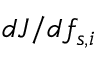Convert formula to latex. <formula><loc_0><loc_0><loc_500><loc_500>{ d J } / { d f _ { s , i } }</formula> 